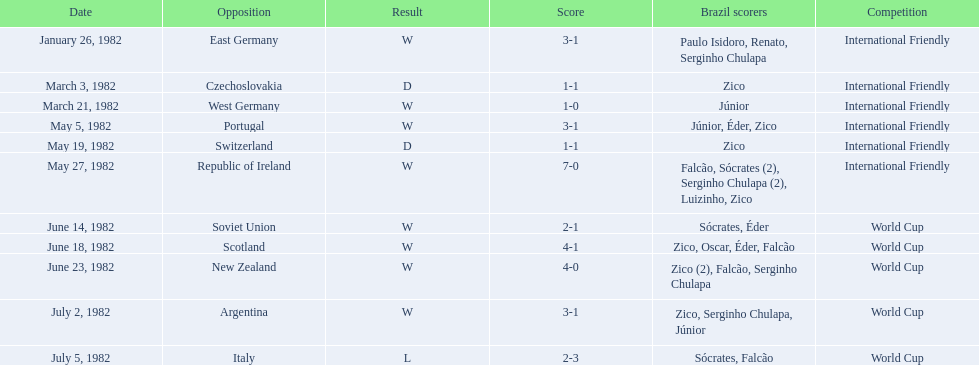What number of goals did brazil achieve against the soviet union? 2-1. What number of goals did brazil achieve against portugal? 3-1. Did brazil accomplish more goals against portugal or the soviet union? Portugal. 